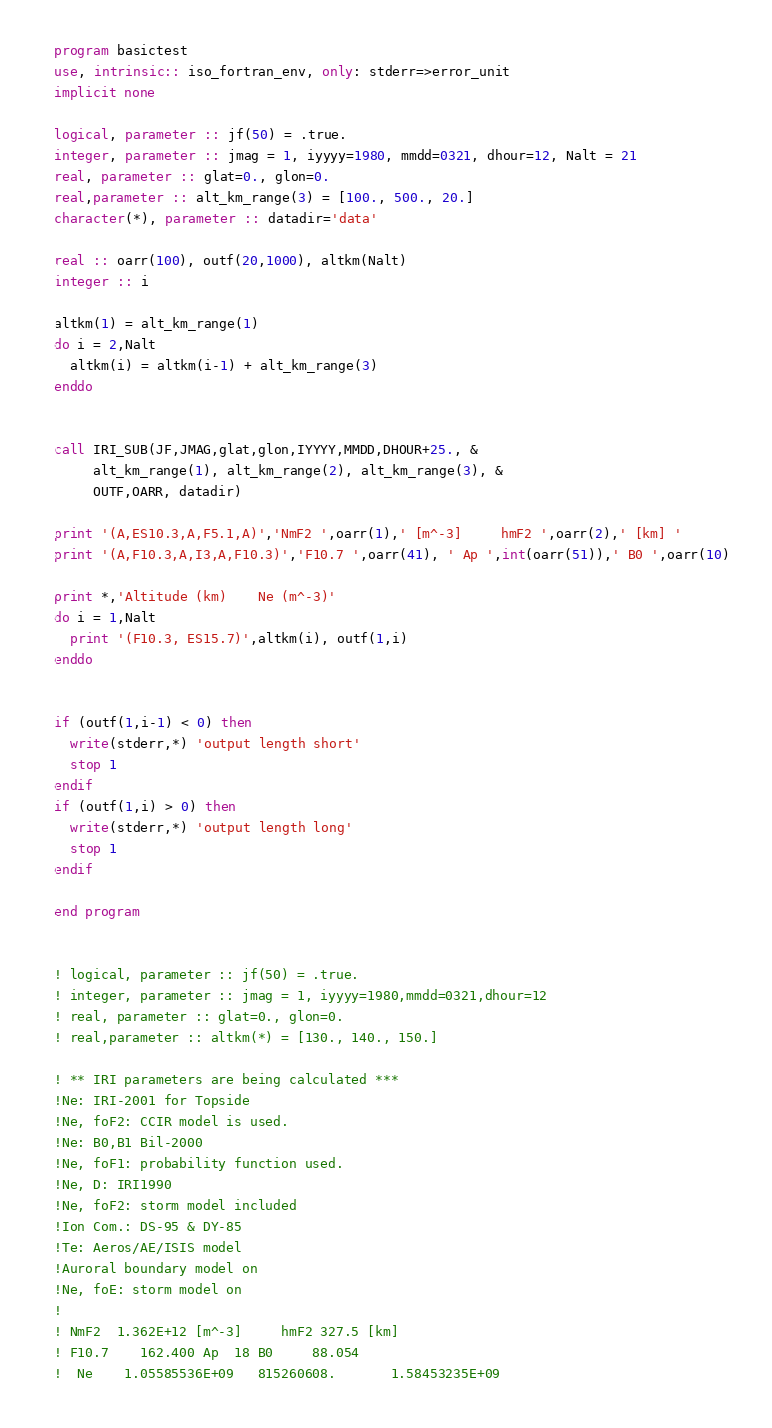Convert code to text. <code><loc_0><loc_0><loc_500><loc_500><_FORTRAN_>program basictest
use, intrinsic:: iso_fortran_env, only: stderr=>error_unit
implicit none

logical, parameter :: jf(50) = .true.
integer, parameter :: jmag = 1, iyyyy=1980, mmdd=0321, dhour=12, Nalt = 21
real, parameter :: glat=0., glon=0.
real,parameter :: alt_km_range(3) = [100., 500., 20.]
character(*), parameter :: datadir='data'

real :: oarr(100), outf(20,1000), altkm(Nalt)
integer :: i

altkm(1) = alt_km_range(1)
do i = 2,Nalt
  altkm(i) = altkm(i-1) + alt_km_range(3)
enddo


call IRI_SUB(JF,JMAG,glat,glon,IYYYY,MMDD,DHOUR+25., &
     alt_km_range(1), alt_km_range(2), alt_km_range(3), &
     OUTF,OARR, datadir)

print '(A,ES10.3,A,F5.1,A)','NmF2 ',oarr(1),' [m^-3]     hmF2 ',oarr(2),' [km] '
print '(A,F10.3,A,I3,A,F10.3)','F10.7 ',oarr(41), ' Ap ',int(oarr(51)),' B0 ',oarr(10)

print *,'Altitude (km)    Ne (m^-3)'
do i = 1,Nalt
  print '(F10.3, ES15.7)',altkm(i), outf(1,i)
enddo


if (outf(1,i-1) < 0) then
  write(stderr,*) 'output length short'
  stop 1
endif
if (outf(1,i) > 0) then
  write(stderr,*) 'output length long'
  stop 1
endif

end program


! logical, parameter :: jf(50) = .true.
! integer, parameter :: jmag = 1, iyyyy=1980,mmdd=0321,dhour=12
! real, parameter :: glat=0., glon=0.
! real,parameter :: altkm(*) = [130., 140., 150.]

! ** IRI parameters are being calculated ***
!Ne: IRI-2001 for Topside
!Ne, foF2: CCIR model is used.
!Ne: B0,B1 Bil-2000
!Ne, foF1: probability function used.
!Ne, D: IRI1990
!Ne, foF2: storm model included
!Ion Com.: DS-95 & DY-85
!Te: Aeros/AE/ISIS model
!Auroral boundary model on
!Ne, foE: storm model on
!
! NmF2  1.362E+12 [m^-3]     hmF2 327.5 [km]
! F10.7    162.400 Ap  18 B0     88.054
!  Ne    1.05585536E+09   815260608.       1.58453235E+09

</code> 